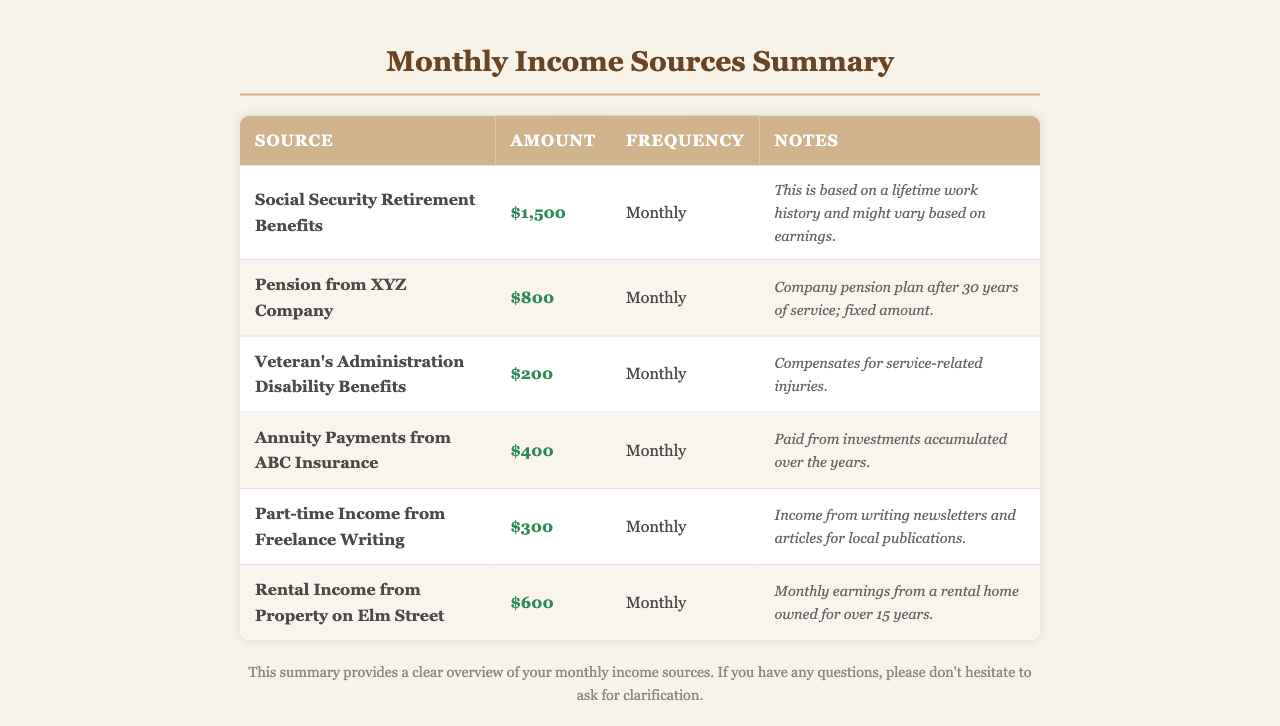What is the amount received from Social Security Retirement Benefits? The document states that the amount received from Social Security Retirement Benefits is $1,500.
Answer: $1,500 How often are the pension payments from XYZ Company received? The document indicates that pension payments from XYZ Company are received monthly.
Answer: Monthly What is the total amount of rental income from the property on Elm Street? The document shows that the rental income from the property on Elm Street is $600.
Answer: $600 What type of income does the part-time freelance writing represent? The document specifies that the part-time income comes from writing newsletters and articles for local publications.
Answer: Freelance Writing How much do Veteran's Administration Disability Benefits amount to each month? According to the document, Veteran's Administration Disability Benefits amount to $200 each month.
Answer: $200 What is the frequency of annuity payments from ABC Insurance? The document states that annuity payments from ABC Insurance are received monthly.
Answer: Monthly Which source provides the highest monthly income? The document indicates that Social Security Retirement Benefits provide the highest monthly income of $1,500.
Answer: Social Security Retirement Benefits What are the notes associated with the pension from XYZ Company? The document mentions that the pension from XYZ Company is a fixed amount after 30 years of service.
Answer: Company pension plan after 30 years of service; fixed amount How much is the total monthly income from all sources listed? By adding all monthly amounts, the total comes to $3,200 ($1,500 + $800 + $200 + $400 + $300 + $600).
Answer: $3,200 